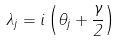Convert formula to latex. <formula><loc_0><loc_0><loc_500><loc_500>\lambda _ { j } = i \left ( \theta _ { j } + \frac { \gamma } 2 \right )</formula> 